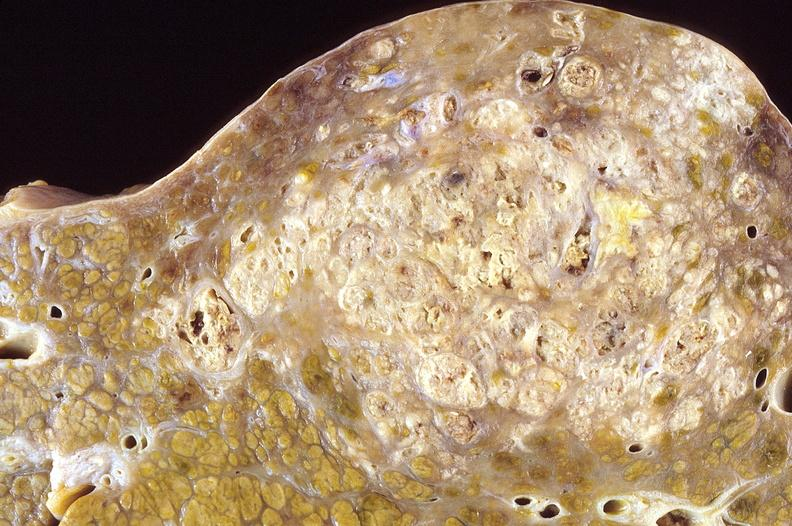s cervical leiomyoma present?
Answer the question using a single word or phrase. No 